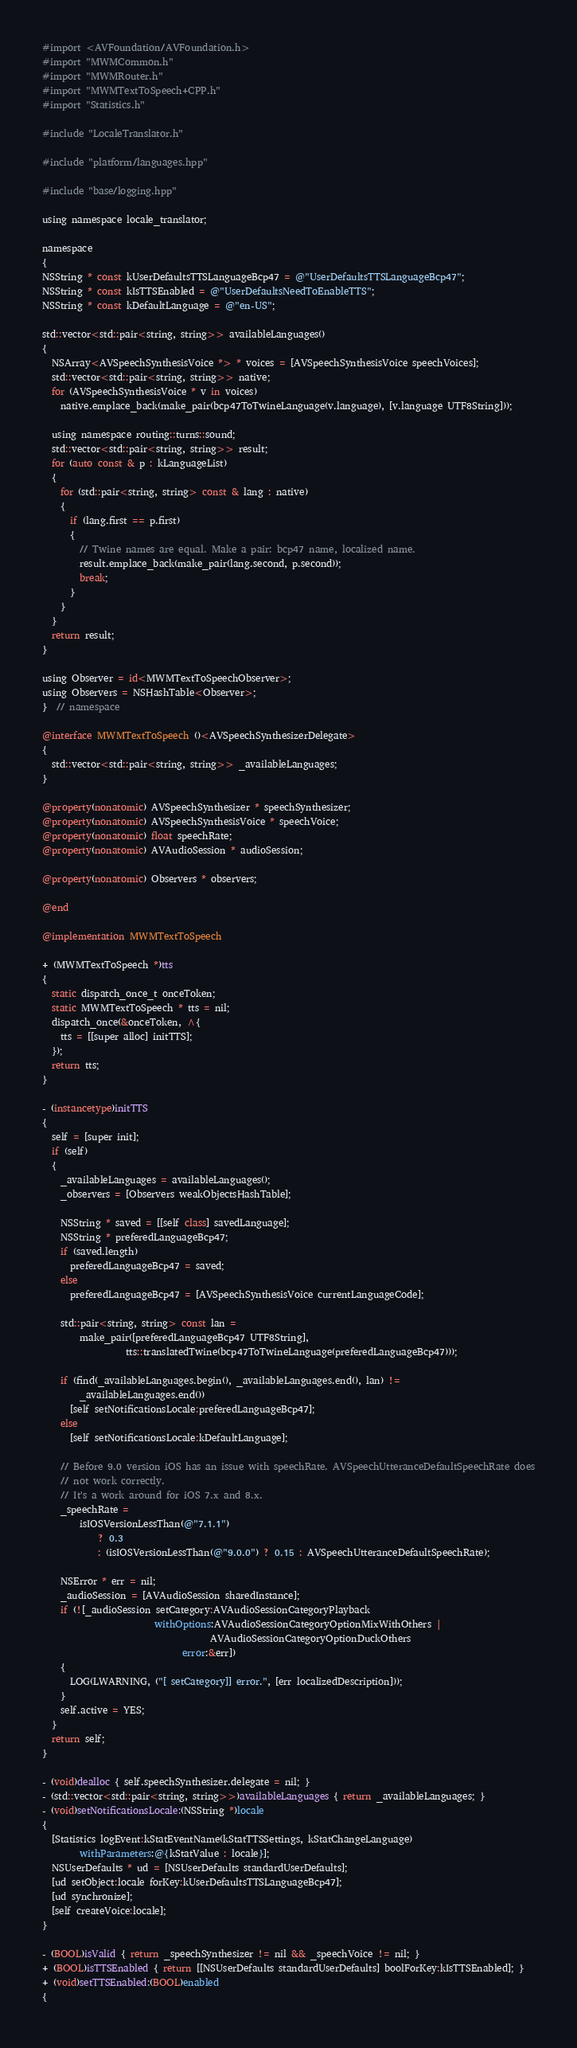Convert code to text. <code><loc_0><loc_0><loc_500><loc_500><_ObjectiveC_>#import <AVFoundation/AVFoundation.h>
#import "MWMCommon.h"
#import "MWMRouter.h"
#import "MWMTextToSpeech+CPP.h"
#import "Statistics.h"

#include "LocaleTranslator.h"

#include "platform/languages.hpp"

#include "base/logging.hpp"

using namespace locale_translator;

namespace
{
NSString * const kUserDefaultsTTSLanguageBcp47 = @"UserDefaultsTTSLanguageBcp47";
NSString * const kIsTTSEnabled = @"UserDefaultsNeedToEnableTTS";
NSString * const kDefaultLanguage = @"en-US";

std::vector<std::pair<string, string>> availableLanguages()
{
  NSArray<AVSpeechSynthesisVoice *> * voices = [AVSpeechSynthesisVoice speechVoices];
  std::vector<std::pair<string, string>> native;
  for (AVSpeechSynthesisVoice * v in voices)
    native.emplace_back(make_pair(bcp47ToTwineLanguage(v.language), [v.language UTF8String]));

  using namespace routing::turns::sound;
  std::vector<std::pair<string, string>> result;
  for (auto const & p : kLanguageList)
  {
    for (std::pair<string, string> const & lang : native)
    {
      if (lang.first == p.first)
      {
        // Twine names are equal. Make a pair: bcp47 name, localized name.
        result.emplace_back(make_pair(lang.second, p.second));
        break;
      }
    }
  }
  return result;
}

using Observer = id<MWMTextToSpeechObserver>;
using Observers = NSHashTable<Observer>;
}  // namespace

@interface MWMTextToSpeech ()<AVSpeechSynthesizerDelegate>
{
  std::vector<std::pair<string, string>> _availableLanguages;
}

@property(nonatomic) AVSpeechSynthesizer * speechSynthesizer;
@property(nonatomic) AVSpeechSynthesisVoice * speechVoice;
@property(nonatomic) float speechRate;
@property(nonatomic) AVAudioSession * audioSession;

@property(nonatomic) Observers * observers;

@end

@implementation MWMTextToSpeech

+ (MWMTextToSpeech *)tts
{
  static dispatch_once_t onceToken;
  static MWMTextToSpeech * tts = nil;
  dispatch_once(&onceToken, ^{
    tts = [[super alloc] initTTS];
  });
  return tts;
}

- (instancetype)initTTS
{
  self = [super init];
  if (self)
  {
    _availableLanguages = availableLanguages();
    _observers = [Observers weakObjectsHashTable];

    NSString * saved = [[self class] savedLanguage];
    NSString * preferedLanguageBcp47;
    if (saved.length)
      preferedLanguageBcp47 = saved;
    else
      preferedLanguageBcp47 = [AVSpeechSynthesisVoice currentLanguageCode];

    std::pair<string, string> const lan =
        make_pair([preferedLanguageBcp47 UTF8String],
                  tts::translatedTwine(bcp47ToTwineLanguage(preferedLanguageBcp47)));

    if (find(_availableLanguages.begin(), _availableLanguages.end(), lan) !=
        _availableLanguages.end())
      [self setNotificationsLocale:preferedLanguageBcp47];
    else
      [self setNotificationsLocale:kDefaultLanguage];

    // Before 9.0 version iOS has an issue with speechRate. AVSpeechUtteranceDefaultSpeechRate does
    // not work correctly.
    // It's a work around for iOS 7.x and 8.x.
    _speechRate =
        isIOSVersionLessThan(@"7.1.1")
            ? 0.3
            : (isIOSVersionLessThan(@"9.0.0") ? 0.15 : AVSpeechUtteranceDefaultSpeechRate);

    NSError * err = nil;
    _audioSession = [AVAudioSession sharedInstance];
    if (![_audioSession setCategory:AVAudioSessionCategoryPlayback
                        withOptions:AVAudioSessionCategoryOptionMixWithOthers |
                                    AVAudioSessionCategoryOptionDuckOthers
                              error:&err])
    {
      LOG(LWARNING, ("[ setCategory]] error.", [err localizedDescription]));
    }
    self.active = YES;
  }
  return self;
}

- (void)dealloc { self.speechSynthesizer.delegate = nil; }
- (std::vector<std::pair<string, string>>)availableLanguages { return _availableLanguages; }
- (void)setNotificationsLocale:(NSString *)locale
{
  [Statistics logEvent:kStatEventName(kStatTTSSettings, kStatChangeLanguage)
        withParameters:@{kStatValue : locale}];
  NSUserDefaults * ud = [NSUserDefaults standardUserDefaults];
  [ud setObject:locale forKey:kUserDefaultsTTSLanguageBcp47];
  [ud synchronize];
  [self createVoice:locale];
}

- (BOOL)isValid { return _speechSynthesizer != nil && _speechVoice != nil; }
+ (BOOL)isTTSEnabled { return [[NSUserDefaults standardUserDefaults] boolForKey:kIsTTSEnabled]; }
+ (void)setTTSEnabled:(BOOL)enabled
{</code> 